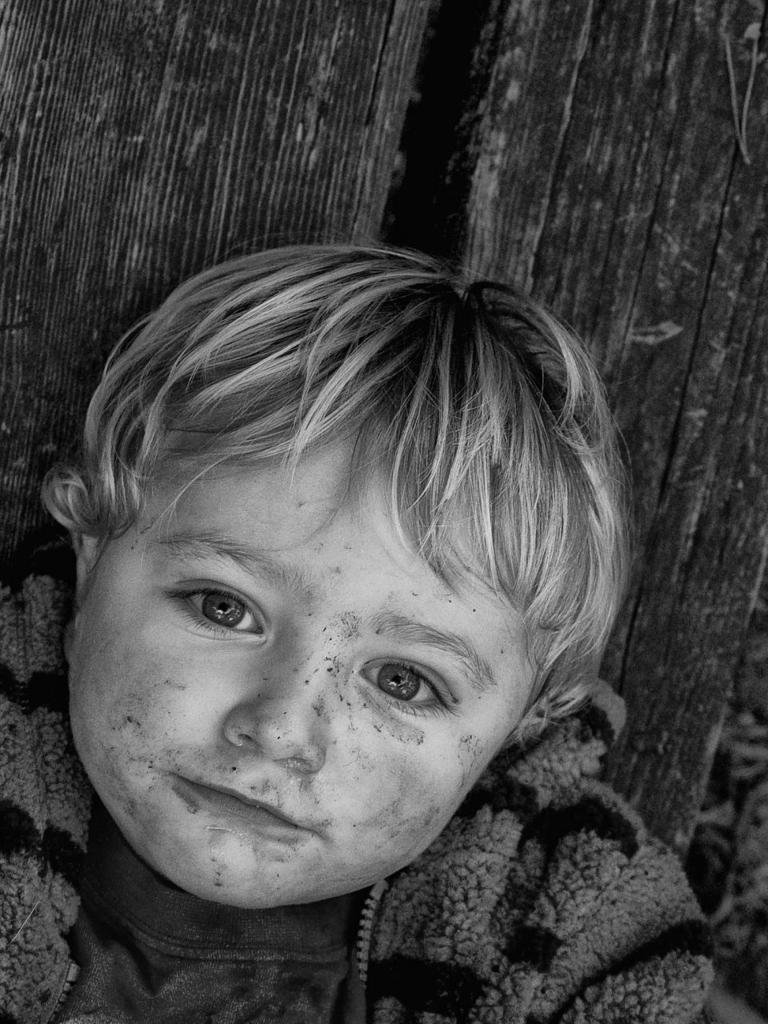What is the main subject of the image? The main subject of the image is a kid. Can you describe the background of the image? There are objects in the background of the image, but their specific details are not mentioned in the provided facts. What is the opinion of the year in the image? There is no reference to a year in the image, so it is not possible to determine its opinion. 